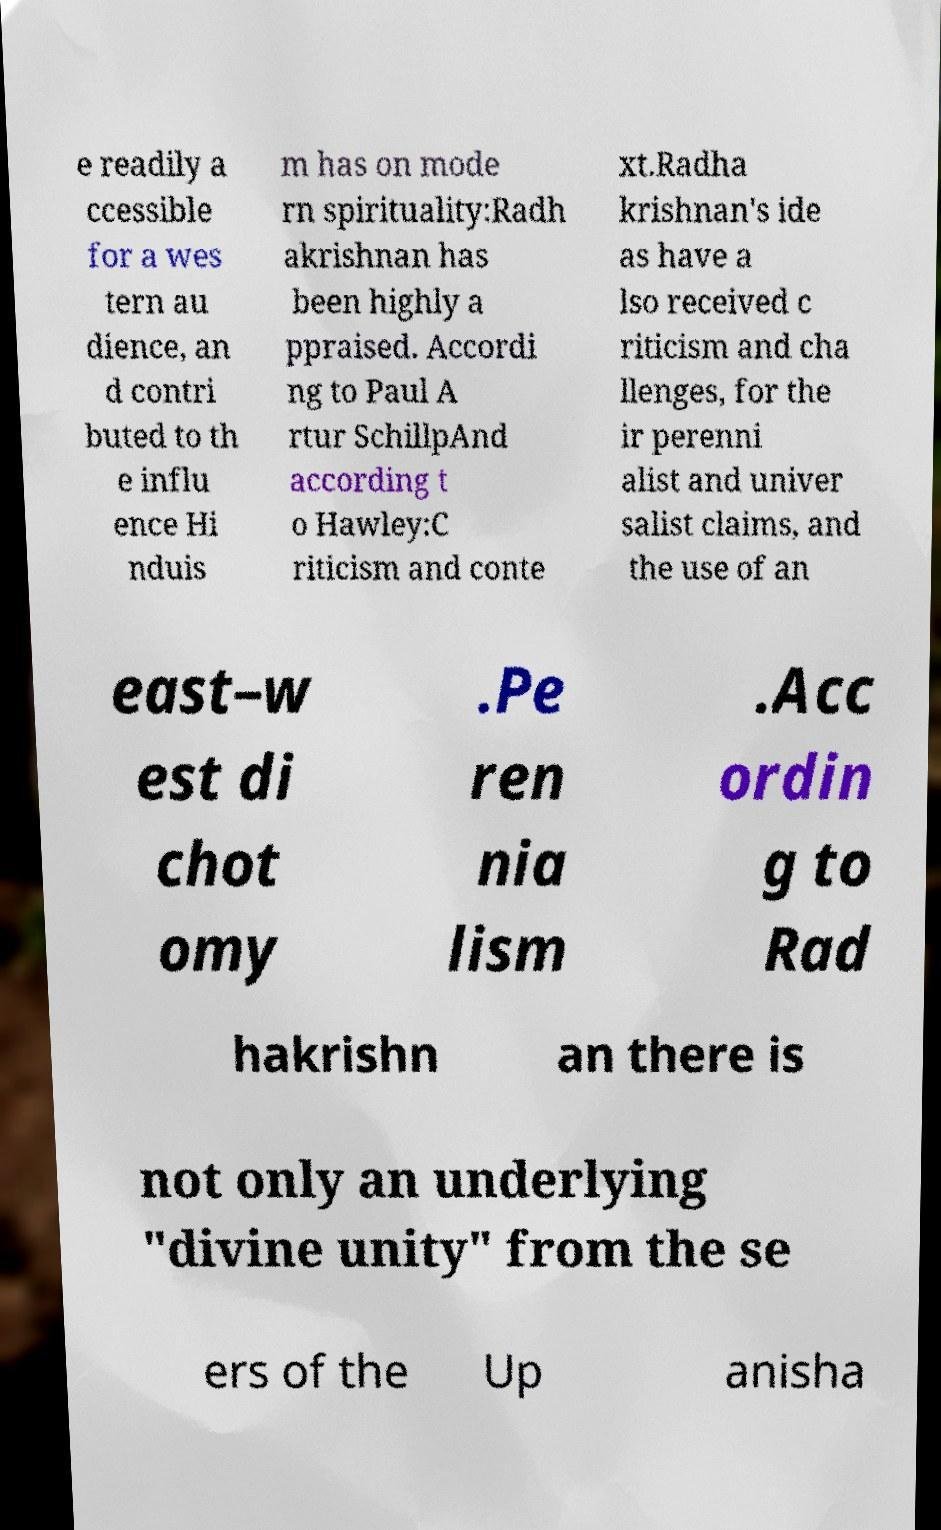What messages or text are displayed in this image? I need them in a readable, typed format. e readily a ccessible for a wes tern au dience, an d contri buted to th e influ ence Hi nduis m has on mode rn spirituality:Radh akrishnan has been highly a ppraised. Accordi ng to Paul A rtur SchillpAnd according t o Hawley:C riticism and conte xt.Radha krishnan's ide as have a lso received c riticism and cha llenges, for the ir perenni alist and univer salist claims, and the use of an east–w est di chot omy .Pe ren nia lism .Acc ordin g to Rad hakrishn an there is not only an underlying "divine unity" from the se ers of the Up anisha 